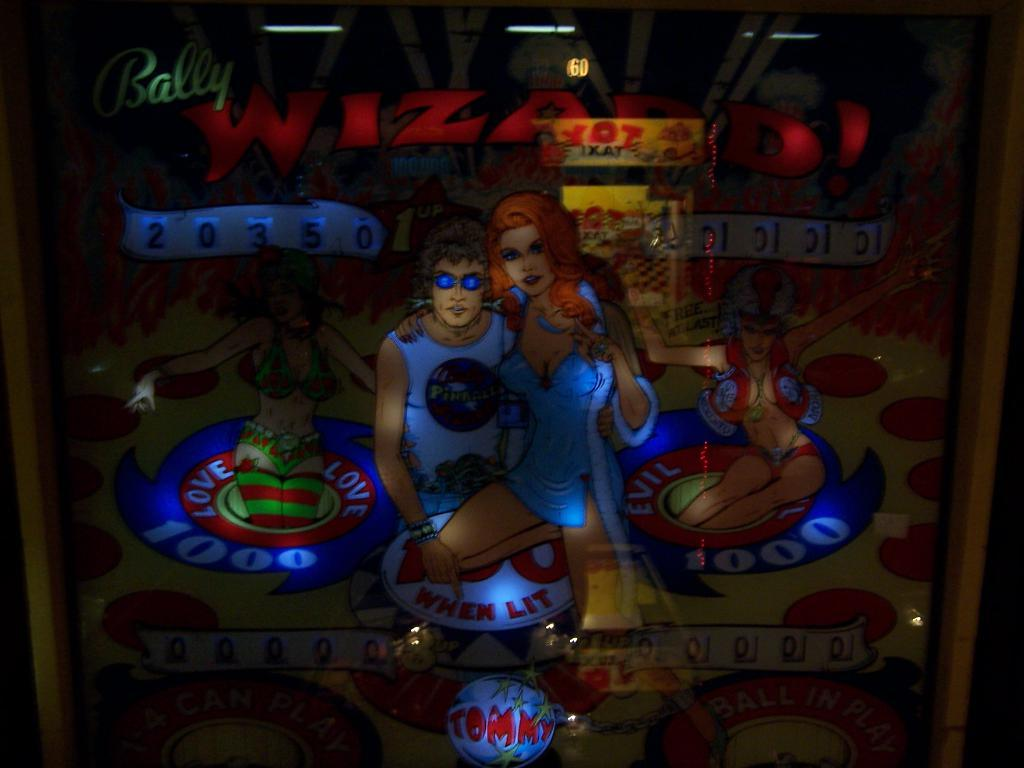Provide a one-sentence caption for the provided image. A vintage game offers both a Love and an Evil side. 